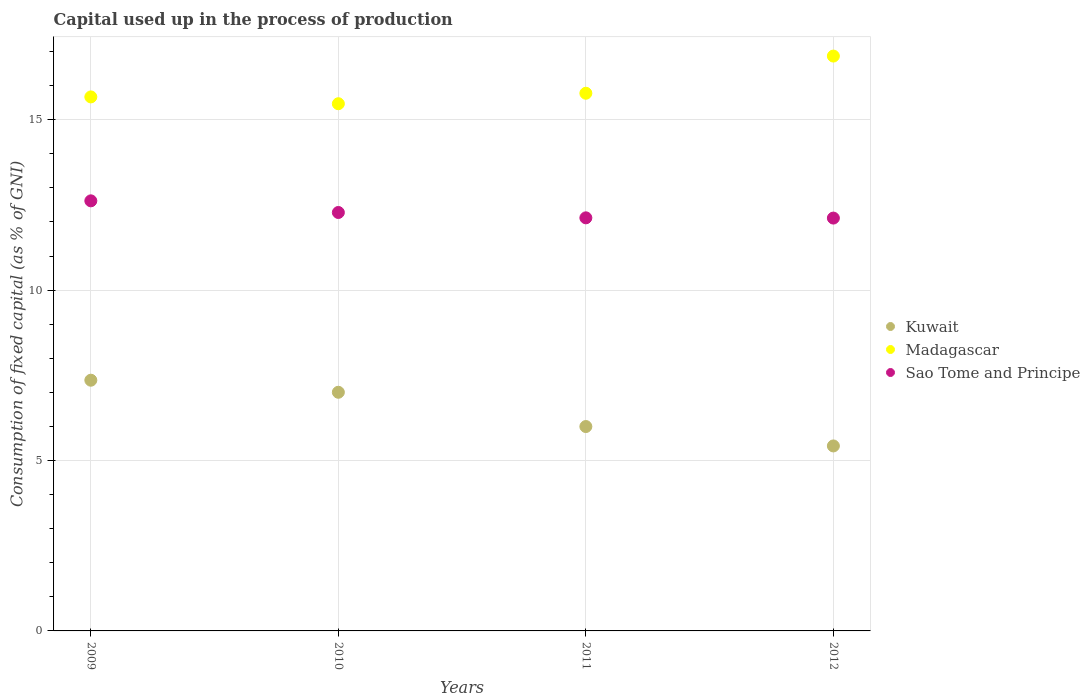How many different coloured dotlines are there?
Offer a terse response. 3. What is the capital used up in the process of production in Kuwait in 2010?
Your answer should be very brief. 7. Across all years, what is the maximum capital used up in the process of production in Kuwait?
Provide a succinct answer. 7.36. Across all years, what is the minimum capital used up in the process of production in Madagascar?
Ensure brevity in your answer.  15.47. In which year was the capital used up in the process of production in Madagascar maximum?
Offer a very short reply. 2012. In which year was the capital used up in the process of production in Madagascar minimum?
Give a very brief answer. 2010. What is the total capital used up in the process of production in Sao Tome and Principe in the graph?
Your response must be concise. 49.13. What is the difference between the capital used up in the process of production in Kuwait in 2009 and that in 2012?
Keep it short and to the point. 1.93. What is the difference between the capital used up in the process of production in Kuwait in 2011 and the capital used up in the process of production in Madagascar in 2009?
Keep it short and to the point. -9.67. What is the average capital used up in the process of production in Madagascar per year?
Offer a terse response. 15.94. In the year 2010, what is the difference between the capital used up in the process of production in Kuwait and capital used up in the process of production in Sao Tome and Principe?
Give a very brief answer. -5.27. What is the ratio of the capital used up in the process of production in Madagascar in 2011 to that in 2012?
Provide a short and direct response. 0.94. Is the capital used up in the process of production in Madagascar in 2010 less than that in 2011?
Provide a short and direct response. Yes. What is the difference between the highest and the second highest capital used up in the process of production in Madagascar?
Give a very brief answer. 1.09. What is the difference between the highest and the lowest capital used up in the process of production in Kuwait?
Make the answer very short. 1.93. In how many years, is the capital used up in the process of production in Kuwait greater than the average capital used up in the process of production in Kuwait taken over all years?
Your response must be concise. 2. Does the capital used up in the process of production in Madagascar monotonically increase over the years?
Ensure brevity in your answer.  No. Are the values on the major ticks of Y-axis written in scientific E-notation?
Make the answer very short. No. Does the graph contain grids?
Your answer should be very brief. Yes. Where does the legend appear in the graph?
Give a very brief answer. Center right. How are the legend labels stacked?
Provide a short and direct response. Vertical. What is the title of the graph?
Ensure brevity in your answer.  Capital used up in the process of production. Does "Sierra Leone" appear as one of the legend labels in the graph?
Keep it short and to the point. No. What is the label or title of the X-axis?
Give a very brief answer. Years. What is the label or title of the Y-axis?
Give a very brief answer. Consumption of fixed capital (as % of GNI). What is the Consumption of fixed capital (as % of GNI) in Kuwait in 2009?
Provide a short and direct response. 7.36. What is the Consumption of fixed capital (as % of GNI) of Madagascar in 2009?
Provide a short and direct response. 15.67. What is the Consumption of fixed capital (as % of GNI) in Sao Tome and Principe in 2009?
Offer a very short reply. 12.62. What is the Consumption of fixed capital (as % of GNI) in Kuwait in 2010?
Your response must be concise. 7. What is the Consumption of fixed capital (as % of GNI) in Madagascar in 2010?
Give a very brief answer. 15.47. What is the Consumption of fixed capital (as % of GNI) of Sao Tome and Principe in 2010?
Keep it short and to the point. 12.28. What is the Consumption of fixed capital (as % of GNI) of Kuwait in 2011?
Your answer should be compact. 6. What is the Consumption of fixed capital (as % of GNI) of Madagascar in 2011?
Your response must be concise. 15.78. What is the Consumption of fixed capital (as % of GNI) of Sao Tome and Principe in 2011?
Your answer should be compact. 12.12. What is the Consumption of fixed capital (as % of GNI) of Kuwait in 2012?
Keep it short and to the point. 5.43. What is the Consumption of fixed capital (as % of GNI) in Madagascar in 2012?
Your response must be concise. 16.87. What is the Consumption of fixed capital (as % of GNI) in Sao Tome and Principe in 2012?
Keep it short and to the point. 12.11. Across all years, what is the maximum Consumption of fixed capital (as % of GNI) in Kuwait?
Your answer should be compact. 7.36. Across all years, what is the maximum Consumption of fixed capital (as % of GNI) of Madagascar?
Give a very brief answer. 16.87. Across all years, what is the maximum Consumption of fixed capital (as % of GNI) of Sao Tome and Principe?
Your answer should be very brief. 12.62. Across all years, what is the minimum Consumption of fixed capital (as % of GNI) of Kuwait?
Offer a terse response. 5.43. Across all years, what is the minimum Consumption of fixed capital (as % of GNI) in Madagascar?
Give a very brief answer. 15.47. Across all years, what is the minimum Consumption of fixed capital (as % of GNI) of Sao Tome and Principe?
Offer a terse response. 12.11. What is the total Consumption of fixed capital (as % of GNI) of Kuwait in the graph?
Give a very brief answer. 25.78. What is the total Consumption of fixed capital (as % of GNI) in Madagascar in the graph?
Keep it short and to the point. 63.78. What is the total Consumption of fixed capital (as % of GNI) in Sao Tome and Principe in the graph?
Ensure brevity in your answer.  49.13. What is the difference between the Consumption of fixed capital (as % of GNI) of Kuwait in 2009 and that in 2010?
Your answer should be compact. 0.35. What is the difference between the Consumption of fixed capital (as % of GNI) of Madagascar in 2009 and that in 2010?
Keep it short and to the point. 0.2. What is the difference between the Consumption of fixed capital (as % of GNI) of Sao Tome and Principe in 2009 and that in 2010?
Your answer should be compact. 0.34. What is the difference between the Consumption of fixed capital (as % of GNI) of Kuwait in 2009 and that in 2011?
Keep it short and to the point. 1.36. What is the difference between the Consumption of fixed capital (as % of GNI) of Madagascar in 2009 and that in 2011?
Give a very brief answer. -0.11. What is the difference between the Consumption of fixed capital (as % of GNI) in Sao Tome and Principe in 2009 and that in 2011?
Offer a very short reply. 0.5. What is the difference between the Consumption of fixed capital (as % of GNI) of Kuwait in 2009 and that in 2012?
Provide a succinct answer. 1.93. What is the difference between the Consumption of fixed capital (as % of GNI) in Madagascar in 2009 and that in 2012?
Your answer should be compact. -1.2. What is the difference between the Consumption of fixed capital (as % of GNI) in Sao Tome and Principe in 2009 and that in 2012?
Provide a succinct answer. 0.51. What is the difference between the Consumption of fixed capital (as % of GNI) of Madagascar in 2010 and that in 2011?
Your answer should be very brief. -0.31. What is the difference between the Consumption of fixed capital (as % of GNI) of Sao Tome and Principe in 2010 and that in 2011?
Your answer should be very brief. 0.16. What is the difference between the Consumption of fixed capital (as % of GNI) in Kuwait in 2010 and that in 2012?
Keep it short and to the point. 1.57. What is the difference between the Consumption of fixed capital (as % of GNI) in Madagascar in 2010 and that in 2012?
Offer a terse response. -1.4. What is the difference between the Consumption of fixed capital (as % of GNI) in Sao Tome and Principe in 2010 and that in 2012?
Make the answer very short. 0.16. What is the difference between the Consumption of fixed capital (as % of GNI) in Kuwait in 2011 and that in 2012?
Give a very brief answer. 0.57. What is the difference between the Consumption of fixed capital (as % of GNI) in Madagascar in 2011 and that in 2012?
Your answer should be very brief. -1.09. What is the difference between the Consumption of fixed capital (as % of GNI) in Sao Tome and Principe in 2011 and that in 2012?
Your answer should be compact. 0.01. What is the difference between the Consumption of fixed capital (as % of GNI) in Kuwait in 2009 and the Consumption of fixed capital (as % of GNI) in Madagascar in 2010?
Give a very brief answer. -8.11. What is the difference between the Consumption of fixed capital (as % of GNI) in Kuwait in 2009 and the Consumption of fixed capital (as % of GNI) in Sao Tome and Principe in 2010?
Provide a short and direct response. -4.92. What is the difference between the Consumption of fixed capital (as % of GNI) of Madagascar in 2009 and the Consumption of fixed capital (as % of GNI) of Sao Tome and Principe in 2010?
Ensure brevity in your answer.  3.39. What is the difference between the Consumption of fixed capital (as % of GNI) in Kuwait in 2009 and the Consumption of fixed capital (as % of GNI) in Madagascar in 2011?
Your answer should be very brief. -8.42. What is the difference between the Consumption of fixed capital (as % of GNI) in Kuwait in 2009 and the Consumption of fixed capital (as % of GNI) in Sao Tome and Principe in 2011?
Offer a terse response. -4.76. What is the difference between the Consumption of fixed capital (as % of GNI) of Madagascar in 2009 and the Consumption of fixed capital (as % of GNI) of Sao Tome and Principe in 2011?
Give a very brief answer. 3.55. What is the difference between the Consumption of fixed capital (as % of GNI) in Kuwait in 2009 and the Consumption of fixed capital (as % of GNI) in Madagascar in 2012?
Your answer should be compact. -9.51. What is the difference between the Consumption of fixed capital (as % of GNI) in Kuwait in 2009 and the Consumption of fixed capital (as % of GNI) in Sao Tome and Principe in 2012?
Offer a very short reply. -4.76. What is the difference between the Consumption of fixed capital (as % of GNI) in Madagascar in 2009 and the Consumption of fixed capital (as % of GNI) in Sao Tome and Principe in 2012?
Make the answer very short. 3.56. What is the difference between the Consumption of fixed capital (as % of GNI) in Kuwait in 2010 and the Consumption of fixed capital (as % of GNI) in Madagascar in 2011?
Offer a very short reply. -8.77. What is the difference between the Consumption of fixed capital (as % of GNI) of Kuwait in 2010 and the Consumption of fixed capital (as % of GNI) of Sao Tome and Principe in 2011?
Keep it short and to the point. -5.12. What is the difference between the Consumption of fixed capital (as % of GNI) in Madagascar in 2010 and the Consumption of fixed capital (as % of GNI) in Sao Tome and Principe in 2011?
Keep it short and to the point. 3.35. What is the difference between the Consumption of fixed capital (as % of GNI) in Kuwait in 2010 and the Consumption of fixed capital (as % of GNI) in Madagascar in 2012?
Your answer should be compact. -9.86. What is the difference between the Consumption of fixed capital (as % of GNI) in Kuwait in 2010 and the Consumption of fixed capital (as % of GNI) in Sao Tome and Principe in 2012?
Provide a succinct answer. -5.11. What is the difference between the Consumption of fixed capital (as % of GNI) in Madagascar in 2010 and the Consumption of fixed capital (as % of GNI) in Sao Tome and Principe in 2012?
Provide a succinct answer. 3.36. What is the difference between the Consumption of fixed capital (as % of GNI) of Kuwait in 2011 and the Consumption of fixed capital (as % of GNI) of Madagascar in 2012?
Offer a very short reply. -10.87. What is the difference between the Consumption of fixed capital (as % of GNI) in Kuwait in 2011 and the Consumption of fixed capital (as % of GNI) in Sao Tome and Principe in 2012?
Keep it short and to the point. -6.12. What is the difference between the Consumption of fixed capital (as % of GNI) of Madagascar in 2011 and the Consumption of fixed capital (as % of GNI) of Sao Tome and Principe in 2012?
Give a very brief answer. 3.66. What is the average Consumption of fixed capital (as % of GNI) in Kuwait per year?
Your response must be concise. 6.45. What is the average Consumption of fixed capital (as % of GNI) in Madagascar per year?
Offer a very short reply. 15.94. What is the average Consumption of fixed capital (as % of GNI) in Sao Tome and Principe per year?
Provide a short and direct response. 12.28. In the year 2009, what is the difference between the Consumption of fixed capital (as % of GNI) in Kuwait and Consumption of fixed capital (as % of GNI) in Madagascar?
Your response must be concise. -8.31. In the year 2009, what is the difference between the Consumption of fixed capital (as % of GNI) of Kuwait and Consumption of fixed capital (as % of GNI) of Sao Tome and Principe?
Keep it short and to the point. -5.26. In the year 2009, what is the difference between the Consumption of fixed capital (as % of GNI) in Madagascar and Consumption of fixed capital (as % of GNI) in Sao Tome and Principe?
Your answer should be compact. 3.05. In the year 2010, what is the difference between the Consumption of fixed capital (as % of GNI) of Kuwait and Consumption of fixed capital (as % of GNI) of Madagascar?
Your response must be concise. -8.47. In the year 2010, what is the difference between the Consumption of fixed capital (as % of GNI) in Kuwait and Consumption of fixed capital (as % of GNI) in Sao Tome and Principe?
Offer a terse response. -5.27. In the year 2010, what is the difference between the Consumption of fixed capital (as % of GNI) in Madagascar and Consumption of fixed capital (as % of GNI) in Sao Tome and Principe?
Make the answer very short. 3.19. In the year 2011, what is the difference between the Consumption of fixed capital (as % of GNI) of Kuwait and Consumption of fixed capital (as % of GNI) of Madagascar?
Ensure brevity in your answer.  -9.78. In the year 2011, what is the difference between the Consumption of fixed capital (as % of GNI) in Kuwait and Consumption of fixed capital (as % of GNI) in Sao Tome and Principe?
Offer a terse response. -6.12. In the year 2011, what is the difference between the Consumption of fixed capital (as % of GNI) in Madagascar and Consumption of fixed capital (as % of GNI) in Sao Tome and Principe?
Your response must be concise. 3.66. In the year 2012, what is the difference between the Consumption of fixed capital (as % of GNI) of Kuwait and Consumption of fixed capital (as % of GNI) of Madagascar?
Your response must be concise. -11.44. In the year 2012, what is the difference between the Consumption of fixed capital (as % of GNI) of Kuwait and Consumption of fixed capital (as % of GNI) of Sao Tome and Principe?
Make the answer very short. -6.69. In the year 2012, what is the difference between the Consumption of fixed capital (as % of GNI) of Madagascar and Consumption of fixed capital (as % of GNI) of Sao Tome and Principe?
Keep it short and to the point. 4.75. What is the ratio of the Consumption of fixed capital (as % of GNI) of Kuwait in 2009 to that in 2010?
Offer a terse response. 1.05. What is the ratio of the Consumption of fixed capital (as % of GNI) of Madagascar in 2009 to that in 2010?
Offer a terse response. 1.01. What is the ratio of the Consumption of fixed capital (as % of GNI) in Sao Tome and Principe in 2009 to that in 2010?
Your answer should be compact. 1.03. What is the ratio of the Consumption of fixed capital (as % of GNI) in Kuwait in 2009 to that in 2011?
Your response must be concise. 1.23. What is the ratio of the Consumption of fixed capital (as % of GNI) in Madagascar in 2009 to that in 2011?
Give a very brief answer. 0.99. What is the ratio of the Consumption of fixed capital (as % of GNI) of Sao Tome and Principe in 2009 to that in 2011?
Your answer should be compact. 1.04. What is the ratio of the Consumption of fixed capital (as % of GNI) of Kuwait in 2009 to that in 2012?
Offer a very short reply. 1.36. What is the ratio of the Consumption of fixed capital (as % of GNI) in Madagascar in 2009 to that in 2012?
Make the answer very short. 0.93. What is the ratio of the Consumption of fixed capital (as % of GNI) in Sao Tome and Principe in 2009 to that in 2012?
Provide a short and direct response. 1.04. What is the ratio of the Consumption of fixed capital (as % of GNI) of Kuwait in 2010 to that in 2011?
Give a very brief answer. 1.17. What is the ratio of the Consumption of fixed capital (as % of GNI) of Madagascar in 2010 to that in 2011?
Ensure brevity in your answer.  0.98. What is the ratio of the Consumption of fixed capital (as % of GNI) in Sao Tome and Principe in 2010 to that in 2011?
Offer a terse response. 1.01. What is the ratio of the Consumption of fixed capital (as % of GNI) in Kuwait in 2010 to that in 2012?
Make the answer very short. 1.29. What is the ratio of the Consumption of fixed capital (as % of GNI) in Madagascar in 2010 to that in 2012?
Offer a terse response. 0.92. What is the ratio of the Consumption of fixed capital (as % of GNI) of Sao Tome and Principe in 2010 to that in 2012?
Keep it short and to the point. 1.01. What is the ratio of the Consumption of fixed capital (as % of GNI) in Kuwait in 2011 to that in 2012?
Ensure brevity in your answer.  1.1. What is the ratio of the Consumption of fixed capital (as % of GNI) in Madagascar in 2011 to that in 2012?
Give a very brief answer. 0.94. What is the ratio of the Consumption of fixed capital (as % of GNI) in Sao Tome and Principe in 2011 to that in 2012?
Your answer should be compact. 1. What is the difference between the highest and the second highest Consumption of fixed capital (as % of GNI) of Kuwait?
Give a very brief answer. 0.35. What is the difference between the highest and the second highest Consumption of fixed capital (as % of GNI) of Sao Tome and Principe?
Keep it short and to the point. 0.34. What is the difference between the highest and the lowest Consumption of fixed capital (as % of GNI) in Kuwait?
Your answer should be compact. 1.93. What is the difference between the highest and the lowest Consumption of fixed capital (as % of GNI) in Madagascar?
Offer a terse response. 1.4. What is the difference between the highest and the lowest Consumption of fixed capital (as % of GNI) of Sao Tome and Principe?
Offer a terse response. 0.51. 